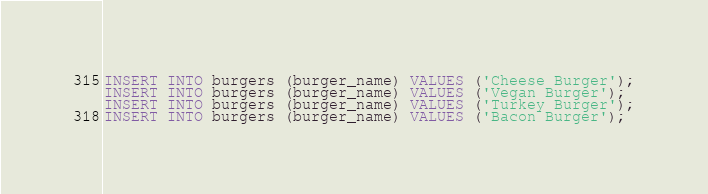<code> <loc_0><loc_0><loc_500><loc_500><_SQL_>INSERT INTO burgers (burger_name) VALUES ('Cheese Burger');
INSERT INTO burgers (burger_name) VALUES ('Vegan Burger');
INSERT INTO burgers (burger_name) VALUES ('Turkey Burger');
INSERT INTO burgers (burger_name) VALUES ('Bacon Burger');
</code> 